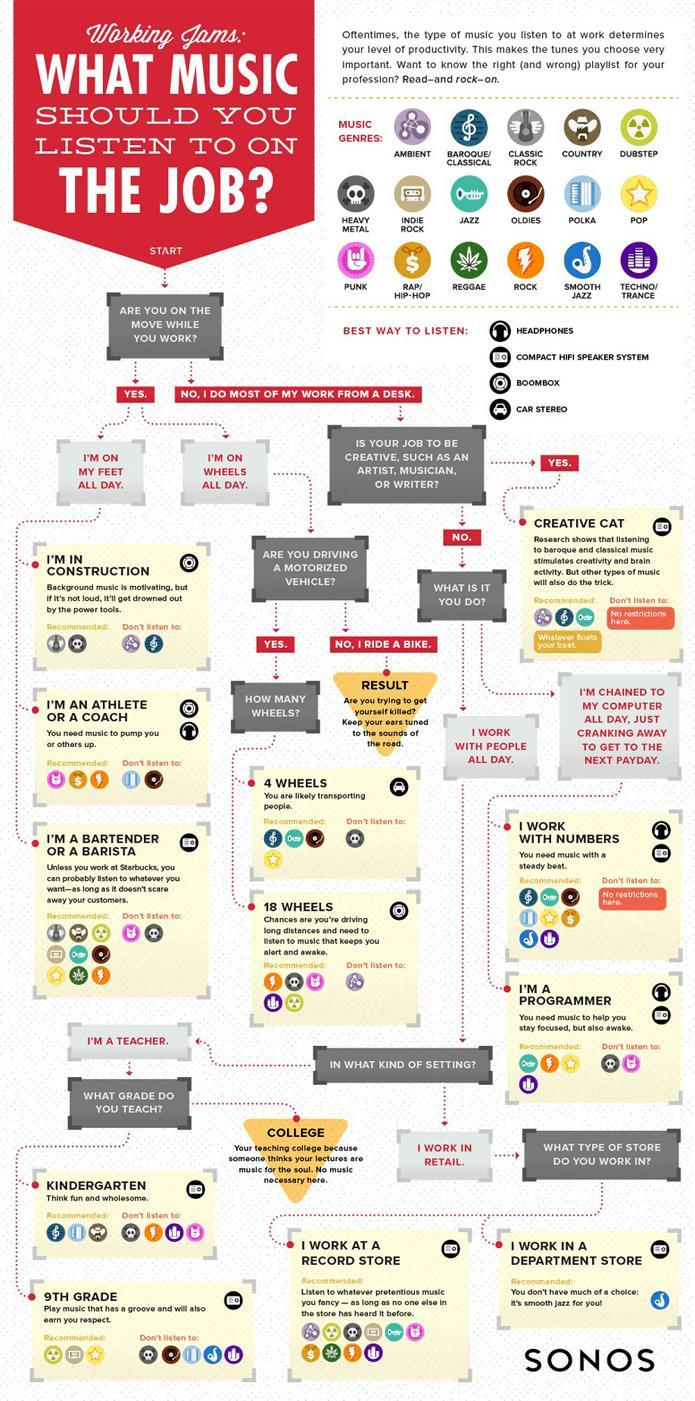Which music genre is represented by a lightning symbol?
Answer the question with a short phrase. ROCK Which type of persons can listen to any type of music? CREATIVE CAT, I WORK WITH NUMBERS If you are driving 4 wheels, which music should you not listen to? HEAVY METAL How many music genres are shown? 17 Which music genre is recommended for an athlete or a coach? PUNK, RAP/HIP-HOP, ROCK If you are driving how many wheels should you not listen to AMBIENT music? 18 WHEELS What is the symbol for POP music- skull, star or dollar? star Which music genre is not recommended for those in construction? AMBIENT, BAROQUE/CLASSICAL 